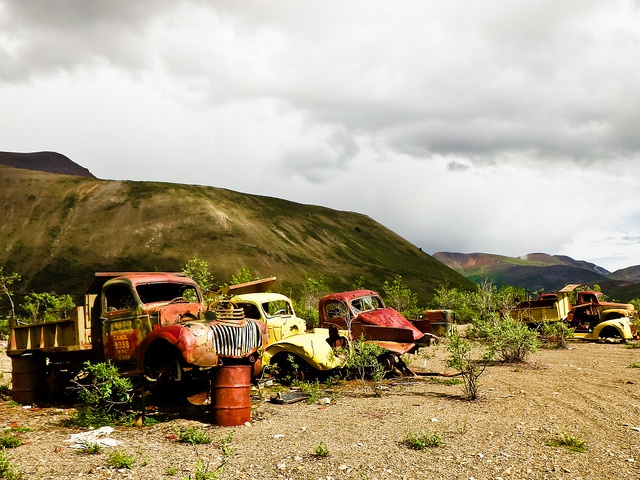Describe the objects in this image and their specific colors. I can see truck in lightgray, black, maroon, olive, and brown tones, truck in lightgray, lightyellow, khaki, black, and olive tones, truck in lightgray, black, maroon, salmon, and olive tones, truck in lightgray, black, olive, and maroon tones, and car in lightgray, lightyellow, khaki, black, and olive tones in this image. 